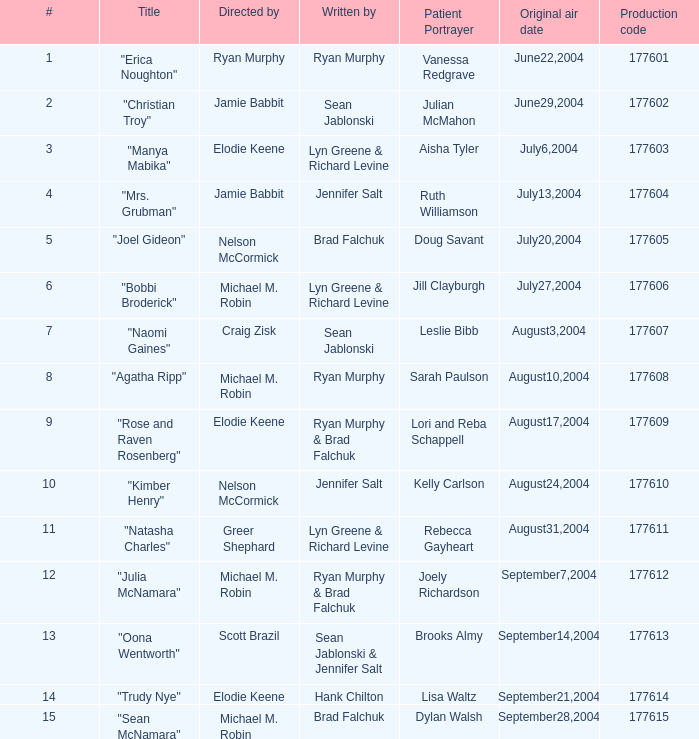What is the episode number of the one titled "naomi gaines"? 20.0. 